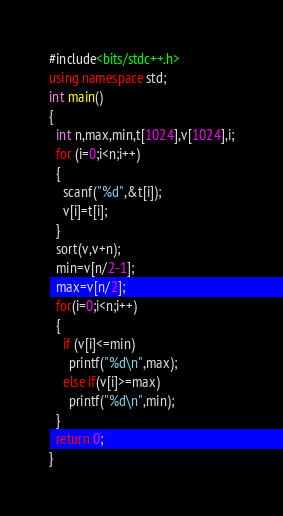Convert code to text. <code><loc_0><loc_0><loc_500><loc_500><_C++_>#include<bits/stdc++.h>
using namespace std;
int main()
{
  int n,max,min,t[1024],v[1024],i;
  for (i=0;i<n;i++)
  {
    scanf("%d",&t[i]);
    v[i]=t[i];
  }
  sort(v,v+n);
  min=v[n/2-1];
  max=v[n/2];
  for(i=0;i<n;i++)
  {
    if (v[i]<=min)
      printf("%d\n",max);
    else if(v[i]>=max)
      printf("%d\n",min);
  }
  return 0;
}</code> 